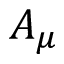<formula> <loc_0><loc_0><loc_500><loc_500>A _ { \mu }</formula> 